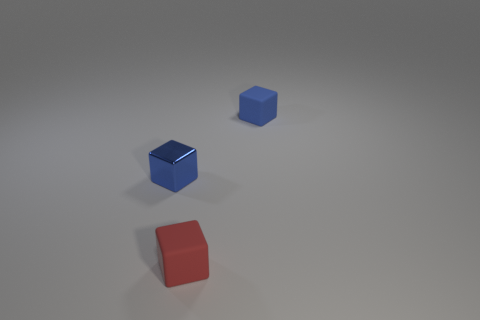The cube that is the same color as the metal thing is what size?
Offer a terse response. Small. What color is the matte object left of the tiny blue rubber cube?
Provide a succinct answer. Red. What is the material of the tiny blue thing that is on the right side of the small blue block that is left of the tiny red matte object?
Offer a very short reply. Rubber. What is the shape of the red thing?
Offer a very short reply. Cube. There is another tiny blue object that is the same shape as the small metal object; what is it made of?
Your answer should be very brief. Rubber. What number of metal blocks are the same size as the red rubber object?
Give a very brief answer. 1. There is a small cube that is on the left side of the small red matte cube; are there any small red things in front of it?
Give a very brief answer. Yes. How many purple objects are either small matte objects or tiny blocks?
Ensure brevity in your answer.  0. The tiny metal block has what color?
Your answer should be very brief. Blue. There is a cube that is the same material as the red object; what is its size?
Your response must be concise. Small. 